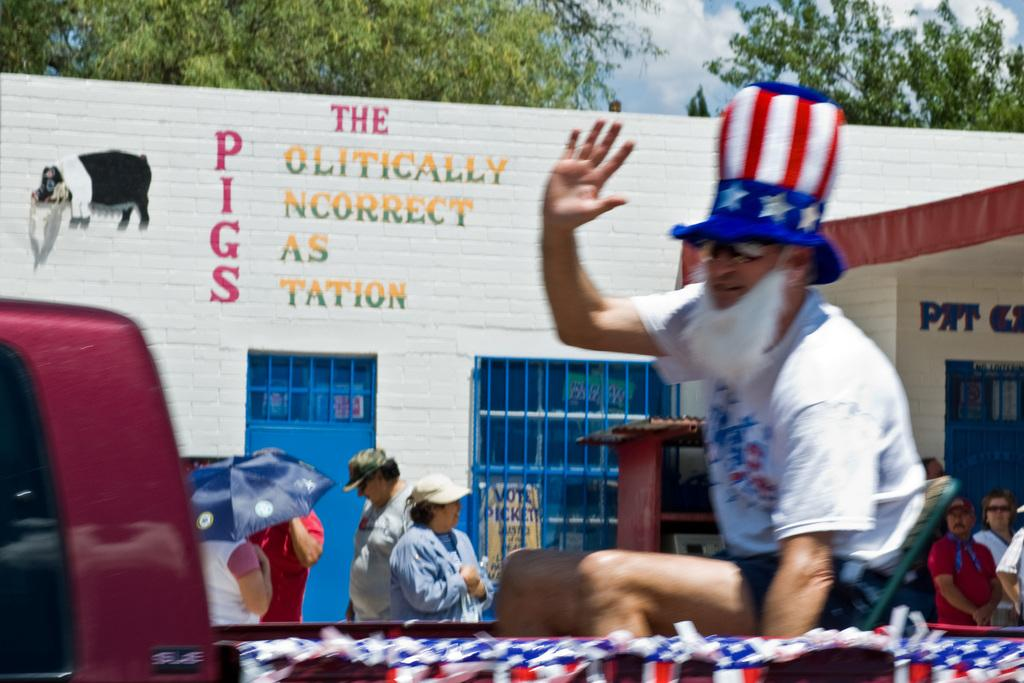<image>
Give a short and clear explanation of the subsequent image. A man dressed in a patriotic hat waves outside of the Politically Incorrect Gas Station. 